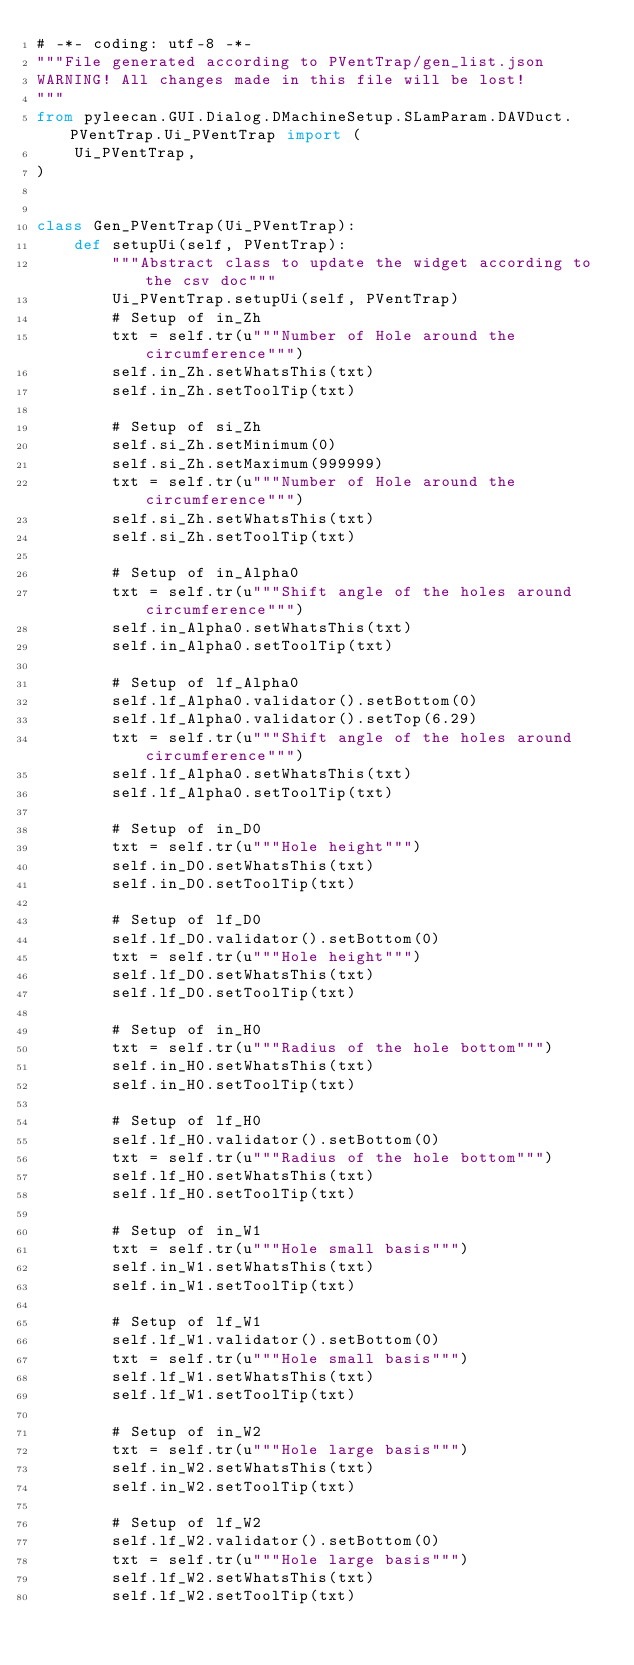<code> <loc_0><loc_0><loc_500><loc_500><_Python_># -*- coding: utf-8 -*-
"""File generated according to PVentTrap/gen_list.json
WARNING! All changes made in this file will be lost!
"""
from pyleecan.GUI.Dialog.DMachineSetup.SLamParam.DAVDuct.PVentTrap.Ui_PVentTrap import (
    Ui_PVentTrap,
)


class Gen_PVentTrap(Ui_PVentTrap):
    def setupUi(self, PVentTrap):
        """Abstract class to update the widget according to the csv doc"""
        Ui_PVentTrap.setupUi(self, PVentTrap)
        # Setup of in_Zh
        txt = self.tr(u"""Number of Hole around the circumference""")
        self.in_Zh.setWhatsThis(txt)
        self.in_Zh.setToolTip(txt)

        # Setup of si_Zh
        self.si_Zh.setMinimum(0)
        self.si_Zh.setMaximum(999999)
        txt = self.tr(u"""Number of Hole around the circumference""")
        self.si_Zh.setWhatsThis(txt)
        self.si_Zh.setToolTip(txt)

        # Setup of in_Alpha0
        txt = self.tr(u"""Shift angle of the holes around circumference""")
        self.in_Alpha0.setWhatsThis(txt)
        self.in_Alpha0.setToolTip(txt)

        # Setup of lf_Alpha0
        self.lf_Alpha0.validator().setBottom(0)
        self.lf_Alpha0.validator().setTop(6.29)
        txt = self.tr(u"""Shift angle of the holes around circumference""")
        self.lf_Alpha0.setWhatsThis(txt)
        self.lf_Alpha0.setToolTip(txt)

        # Setup of in_D0
        txt = self.tr(u"""Hole height""")
        self.in_D0.setWhatsThis(txt)
        self.in_D0.setToolTip(txt)

        # Setup of lf_D0
        self.lf_D0.validator().setBottom(0)
        txt = self.tr(u"""Hole height""")
        self.lf_D0.setWhatsThis(txt)
        self.lf_D0.setToolTip(txt)

        # Setup of in_H0
        txt = self.tr(u"""Radius of the hole bottom""")
        self.in_H0.setWhatsThis(txt)
        self.in_H0.setToolTip(txt)

        # Setup of lf_H0
        self.lf_H0.validator().setBottom(0)
        txt = self.tr(u"""Radius of the hole bottom""")
        self.lf_H0.setWhatsThis(txt)
        self.lf_H0.setToolTip(txt)

        # Setup of in_W1
        txt = self.tr(u"""Hole small basis""")
        self.in_W1.setWhatsThis(txt)
        self.in_W1.setToolTip(txt)

        # Setup of lf_W1
        self.lf_W1.validator().setBottom(0)
        txt = self.tr(u"""Hole small basis""")
        self.lf_W1.setWhatsThis(txt)
        self.lf_W1.setToolTip(txt)

        # Setup of in_W2
        txt = self.tr(u"""Hole large basis""")
        self.in_W2.setWhatsThis(txt)
        self.in_W2.setToolTip(txt)

        # Setup of lf_W2
        self.lf_W2.validator().setBottom(0)
        txt = self.tr(u"""Hole large basis""")
        self.lf_W2.setWhatsThis(txt)
        self.lf_W2.setToolTip(txt)
</code> 